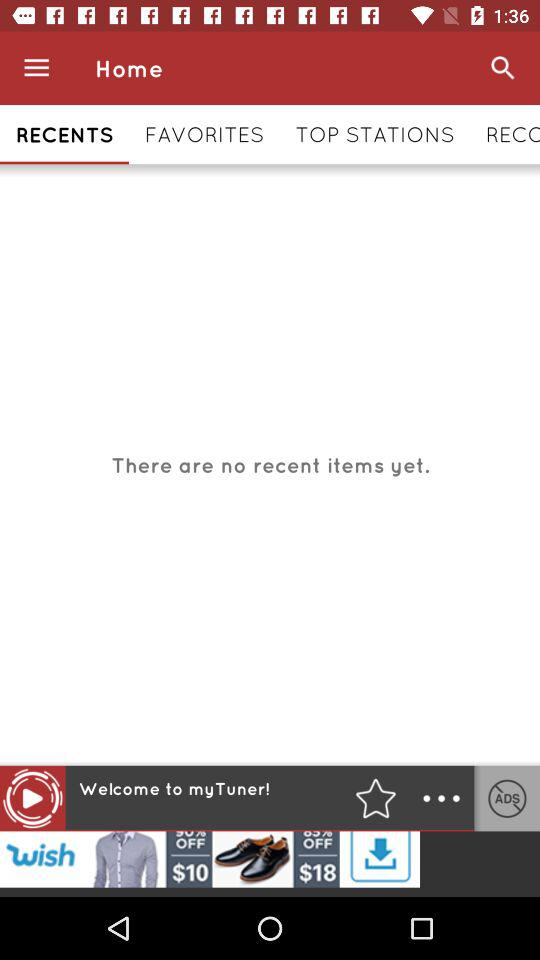Which tab is selected? The selected tab is "RECENTS". 